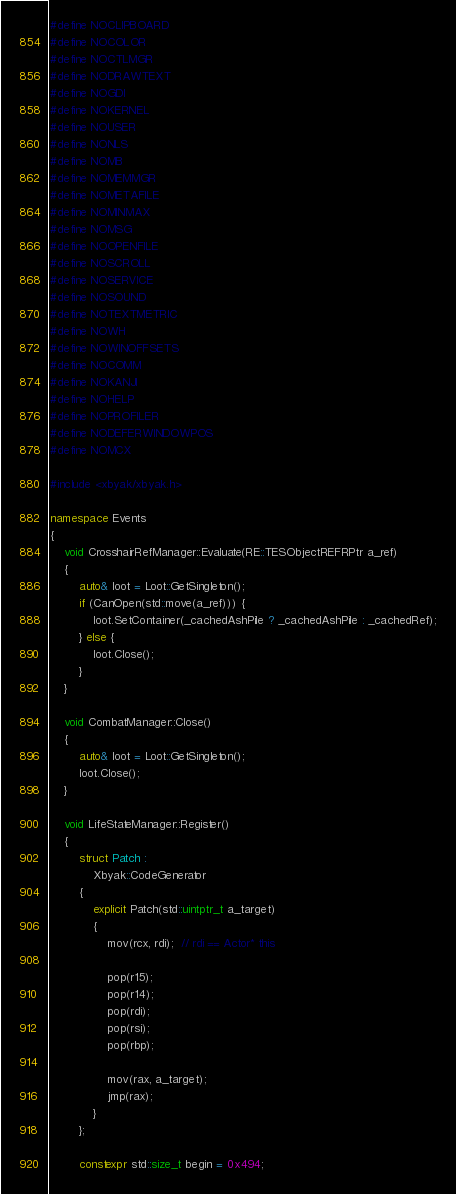<code> <loc_0><loc_0><loc_500><loc_500><_C++_>#define NOCLIPBOARD
#define NOCOLOR
#define NOCTLMGR
#define NODRAWTEXT
#define NOGDI
#define NOKERNEL
#define NOUSER
#define NONLS
#define NOMB
#define NOMEMMGR
#define NOMETAFILE
#define NOMINMAX
#define NOMSG
#define NOOPENFILE
#define NOSCROLL
#define NOSERVICE
#define NOSOUND
#define NOTEXTMETRIC
#define NOWH
#define NOWINOFFSETS
#define NOCOMM
#define NOKANJI
#define NOHELP
#define NOPROFILER
#define NODEFERWINDOWPOS
#define NOMCX

#include <xbyak/xbyak.h>

namespace Events
{
	void CrosshairRefManager::Evaluate(RE::TESObjectREFRPtr a_ref)
	{
		auto& loot = Loot::GetSingleton();
		if (CanOpen(std::move(a_ref))) {
			loot.SetContainer(_cachedAshPile ? _cachedAshPile : _cachedRef);
		} else {
			loot.Close();
		}
	}

	void CombatManager::Close()
	{
		auto& loot = Loot::GetSingleton();
		loot.Close();
	}

	void LifeStateManager::Register()
	{
		struct Patch :
			Xbyak::CodeGenerator
		{
			explicit Patch(std::uintptr_t a_target)
			{
				mov(rcx, rdi);  // rdi == Actor* this

				pop(r15);
				pop(r14);
				pop(rdi);
				pop(rsi);
				pop(rbp);

				mov(rax, a_target);
				jmp(rax);
			}
		};

		constexpr std::size_t begin = 0x494;</code> 